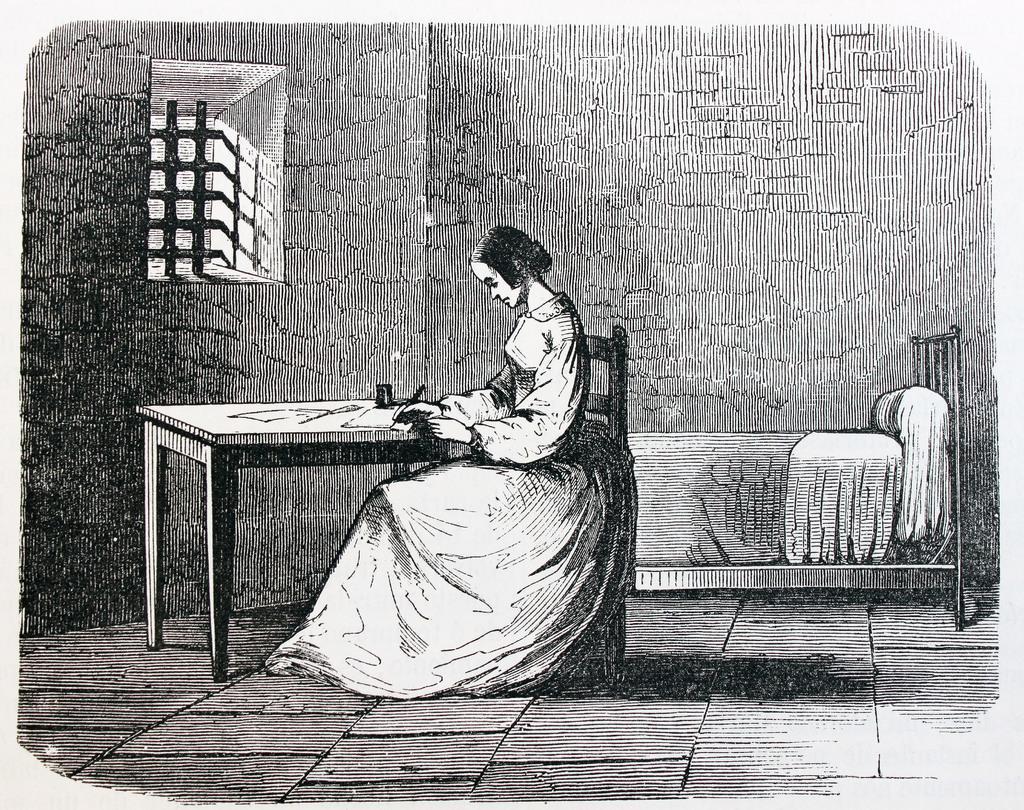In one or two sentences, can you explain what this image depicts? In this image I can see the person is sitting on the chair and holding something. I can see the bed, wall, window and few objects on the table. The image is in black and white. 